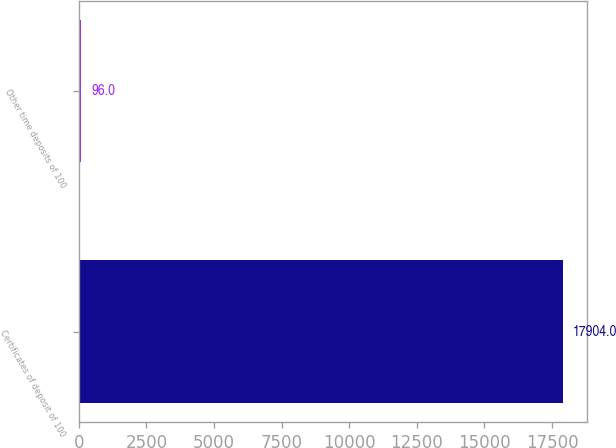Convert chart. <chart><loc_0><loc_0><loc_500><loc_500><bar_chart><fcel>Certificates of deposit of 100<fcel>Other time deposits of 100<nl><fcel>17904<fcel>96<nl></chart> 